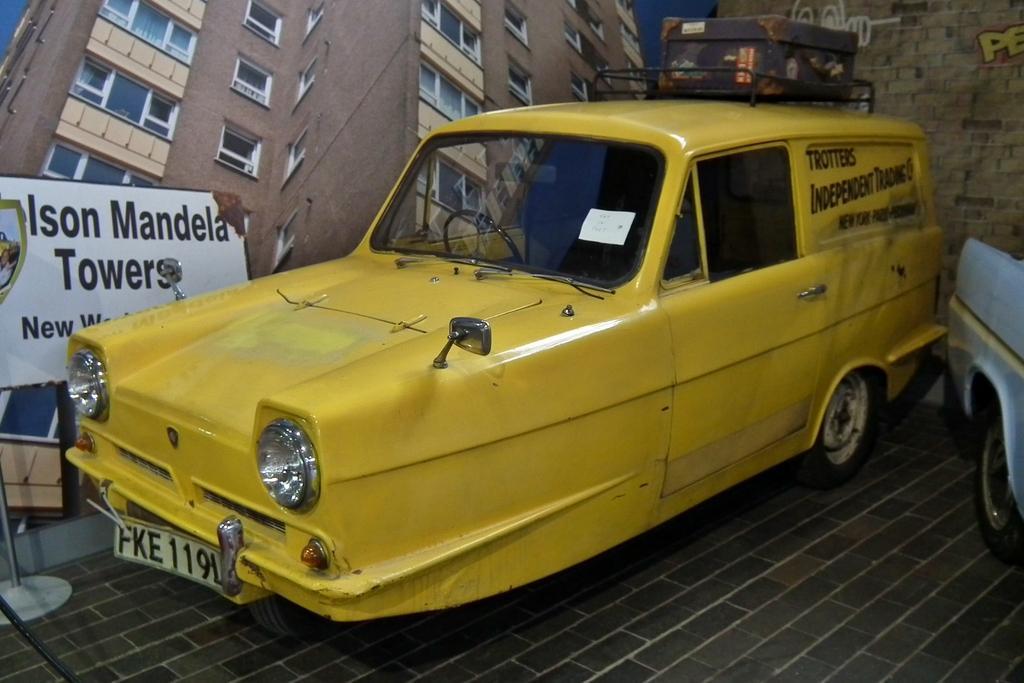In one or two sentences, can you explain what this image depicts? In this image we can see two cars on the floor, beside the car there is a wall with poster of a building and a board with text and a wall with text in the background. 